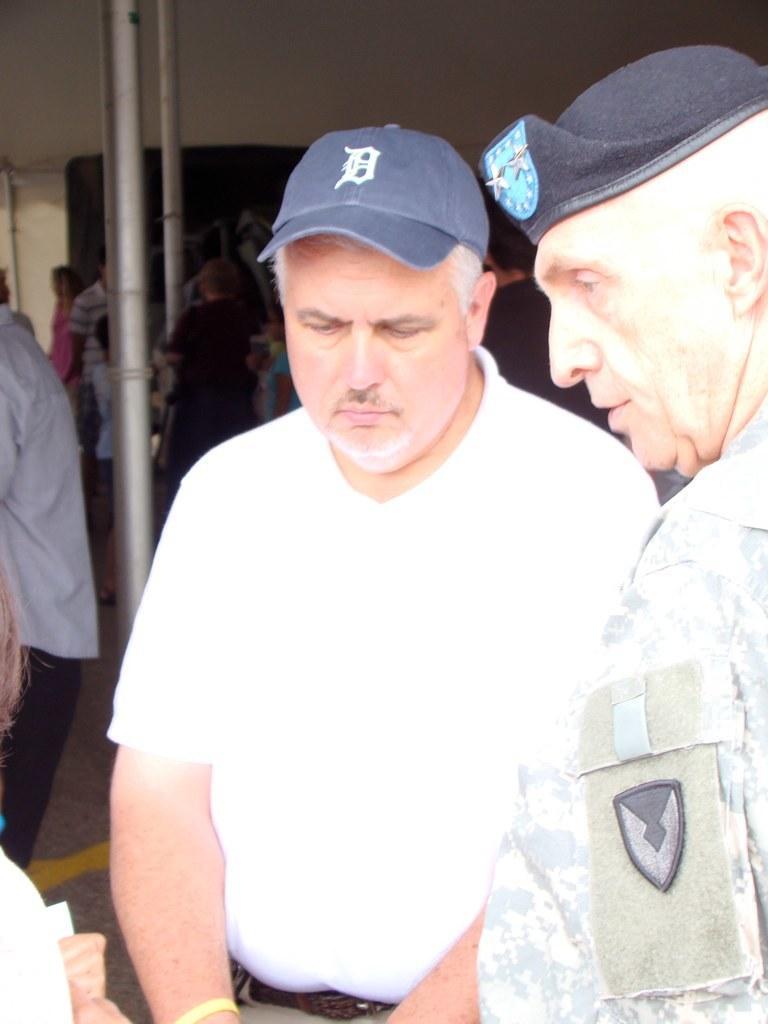Can you describe this image briefly? In this image there are a few people standing. Behind them there are poles. At the background there is a wall. 